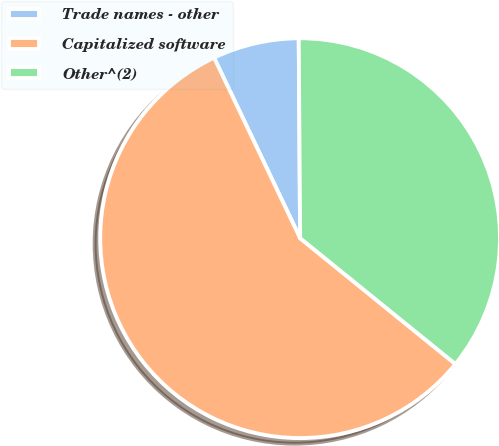<chart> <loc_0><loc_0><loc_500><loc_500><pie_chart><fcel>Trade names - other<fcel>Capitalized software<fcel>Other^(2)<nl><fcel>6.97%<fcel>57.08%<fcel>35.95%<nl></chart> 